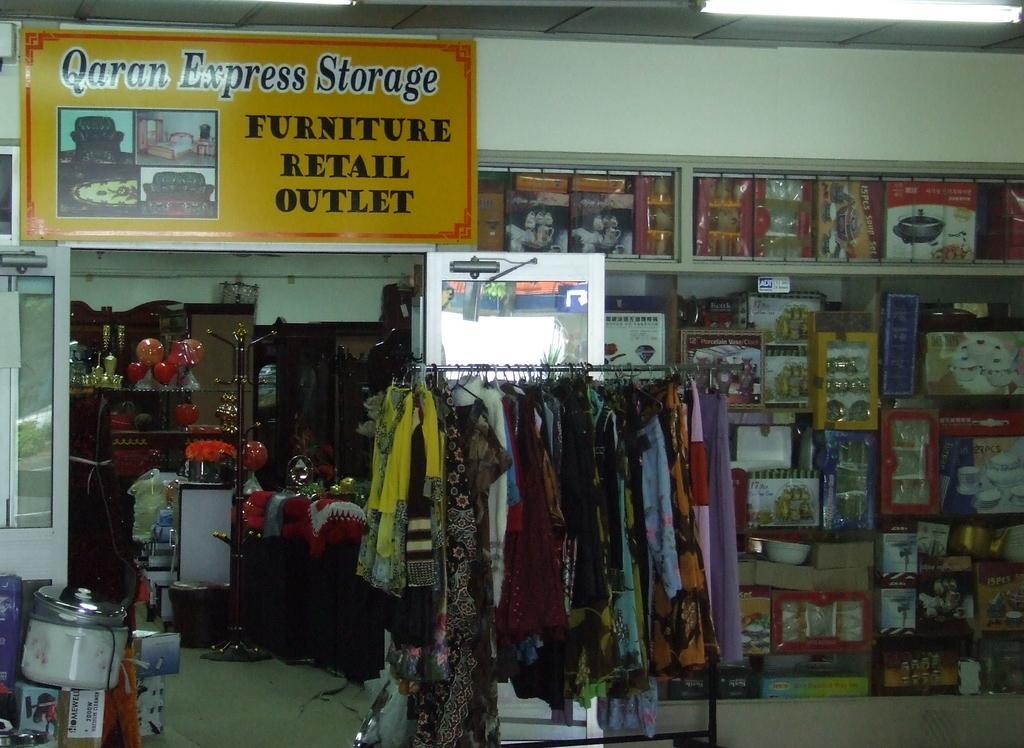Please provide a concise description of this image. In this picture we can see the cloth store. In the front there are some clothes hanging on the stand. Behind we can see the household products in the shelf. On the top we can see the yellow naming board on which "Qaran Express storage" is written. Behind we can the wooden furniture. 